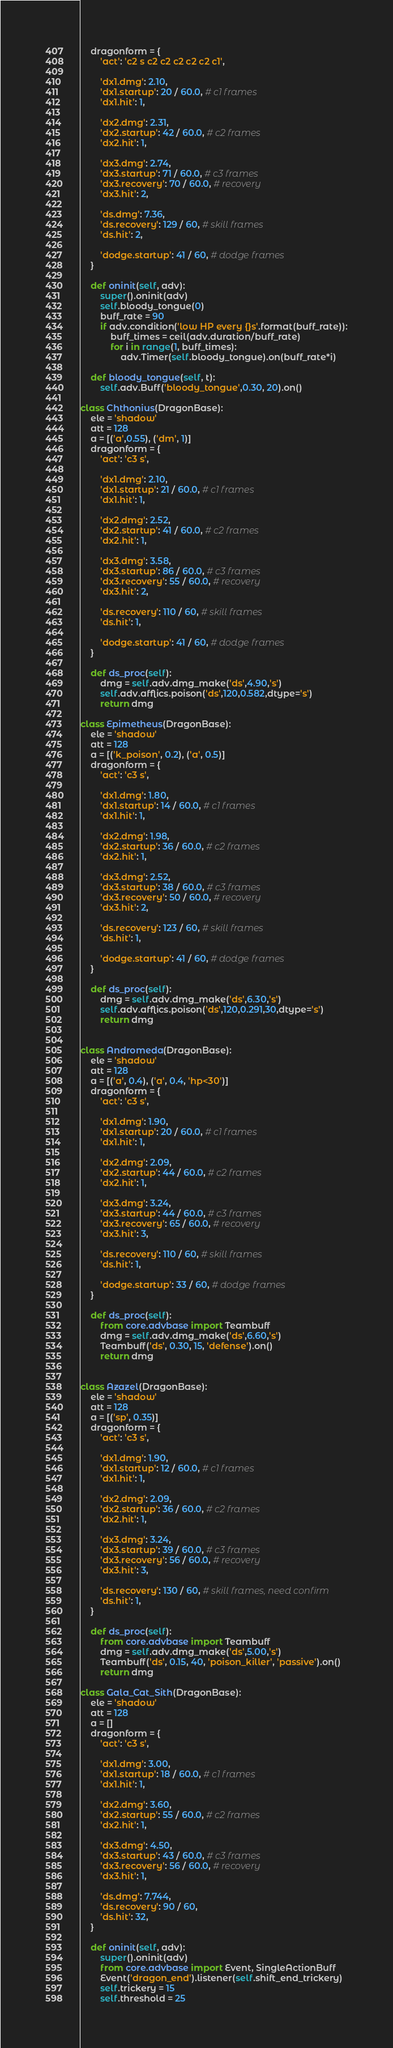<code> <loc_0><loc_0><loc_500><loc_500><_Python_>    dragonform = {
        'act': 'c2 s c2 c2 c2 c2 c2 c1',

        'dx1.dmg': 2.10,
        'dx1.startup': 20 / 60.0, # c1 frames
        'dx1.hit': 1,

        'dx2.dmg': 2.31,
        'dx2.startup': 42 / 60.0, # c2 frames
        'dx2.hit': 1,

        'dx3.dmg': 2.74,
        'dx3.startup': 71 / 60.0, # c3 frames
        'dx3.recovery': 70 / 60.0, # recovery
        'dx3.hit': 2,

        'ds.dmg': 7.36,
        'ds.recovery': 129 / 60, # skill frames
        'ds.hit': 2,

        'dodge.startup': 41 / 60, # dodge frames
    }

    def oninit(self, adv):
        super().oninit(adv)
        self.bloody_tongue(0)
        buff_rate = 90
        if adv.condition('low HP every {}s'.format(buff_rate)):
            buff_times = ceil(adv.duration/buff_rate)
            for i in range(1, buff_times):
                adv.Timer(self.bloody_tongue).on(buff_rate*i)

    def bloody_tongue(self, t):
        self.adv.Buff('bloody_tongue',0.30, 20).on()

class Chthonius(DragonBase):
    ele = 'shadow'
    att = 128
    a = [('a',0.55), ('dm', 1)]
    dragonform = {
        'act': 'c3 s',

        'dx1.dmg': 2.10,
        'dx1.startup': 21 / 60.0, # c1 frames
        'dx1.hit': 1,

        'dx2.dmg': 2.52,
        'dx2.startup': 41 / 60.0, # c2 frames
        'dx2.hit': 1,

        'dx3.dmg': 3.58,
        'dx3.startup': 86 / 60.0, # c3 frames
        'dx3.recovery': 55 / 60.0, # recovery
        'dx3.hit': 2,

        'ds.recovery': 110 / 60, # skill frames
        'ds.hit': 1,

        'dodge.startup': 41 / 60, # dodge frames
    }

    def ds_proc(self):
        dmg = self.adv.dmg_make('ds',4.90,'s')
        self.adv.afflics.poison('ds',120,0.582,dtype='s')
        return dmg

class Epimetheus(DragonBase):
    ele = 'shadow'
    att = 128
    a = [('k_poison', 0.2), ('a', 0.5)]
    dragonform = {
        'act': 'c3 s',

        'dx1.dmg': 1.80,
        'dx1.startup': 14 / 60.0, # c1 frames
        'dx1.hit': 1,

        'dx2.dmg': 1.98,
        'dx2.startup': 36 / 60.0, # c2 frames
        'dx2.hit': 1,

        'dx3.dmg': 2.52,
        'dx3.startup': 38 / 60.0, # c3 frames
        'dx3.recovery': 50 / 60.0, # recovery
        'dx3.hit': 2,

        'ds.recovery': 123 / 60, # skill frames
        'ds.hit': 1,

        'dodge.startup': 41 / 60, # dodge frames
    }

    def ds_proc(self):
        dmg = self.adv.dmg_make('ds',6.30,'s')
        self.adv.afflics.poison('ds',120,0.291,30,dtype='s')
        return dmg


class Andromeda(DragonBase):
    ele = 'shadow'
    att = 128
    a = [('a', 0.4), ('a', 0.4, 'hp<30')]
    dragonform = {
        'act': 'c3 s',

        'dx1.dmg': 1.90,
        'dx1.startup': 20 / 60.0, # c1 frames
        'dx1.hit': 1,

        'dx2.dmg': 2.09,
        'dx2.startup': 44 / 60.0, # c2 frames
        'dx2.hit': 1,

        'dx3.dmg': 3.24,
        'dx3.startup': 44 / 60.0, # c3 frames
        'dx3.recovery': 65 / 60.0, # recovery
        'dx3.hit': 3,

        'ds.recovery': 110 / 60, # skill frames
        'ds.hit': 1,

        'dodge.startup': 33 / 60, # dodge frames
    }

    def ds_proc(self):
        from core.advbase import Teambuff
        dmg = self.adv.dmg_make('ds',6.60,'s')
        Teambuff('ds', 0.30, 15, 'defense').on()
        return dmg


class Azazel(DragonBase):
    ele = 'shadow'
    att = 128
    a = [('sp', 0.35)]
    dragonform = {
        'act': 'c3 s',

        'dx1.dmg': 1.90,
        'dx1.startup': 12 / 60.0, # c1 frames
        'dx1.hit': 1,

        'dx2.dmg': 2.09,
        'dx2.startup': 36 / 60.0, # c2 frames
        'dx2.hit': 1,

        'dx3.dmg': 3.24,
        'dx3.startup': 39 / 60.0, # c3 frames
        'dx3.recovery': 56 / 60.0, # recovery
        'dx3.hit': 3,

        'ds.recovery': 130 / 60, # skill frames, need confirm
        'ds.hit': 1,
    }

    def ds_proc(self):
        from core.advbase import Teambuff
        dmg = self.adv.dmg_make('ds',5.00,'s')
        Teambuff('ds', 0.15, 40, 'poison_killer', 'passive').on()
        return dmg

class Gala_Cat_Sith(DragonBase):
    ele = 'shadow'
    att = 128
    a = []
    dragonform = {
        'act': 'c3 s',

        'dx1.dmg': 3.00,
        'dx1.startup': 18 / 60.0, # c1 frames
        'dx1.hit': 1,

        'dx2.dmg': 3.60,
        'dx2.startup': 55 / 60.0, # c2 frames
        'dx2.hit': 1,

        'dx3.dmg': 4.50,
        'dx3.startup': 43 / 60.0, # c3 frames
        'dx3.recovery': 56 / 60.0, # recovery
        'dx3.hit': 1,

        'ds.dmg': 7.744,
        'ds.recovery': 90 / 60,
        'ds.hit': 32,
    }

    def oninit(self, adv):
        super().oninit(adv)
        from core.advbase import Event, SingleActionBuff
        Event('dragon_end').listener(self.shift_end_trickery)
        self.trickery = 15
        self.threshold = 25</code> 